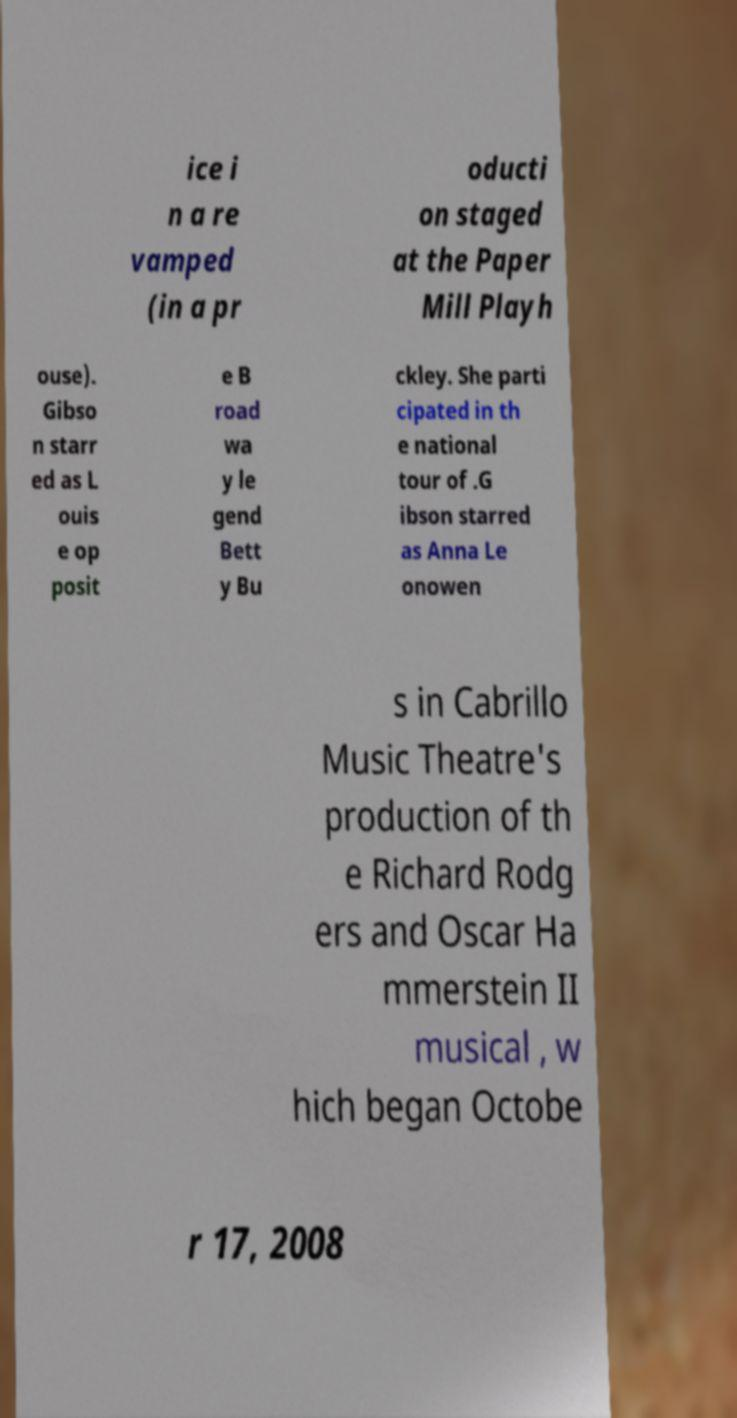What messages or text are displayed in this image? I need them in a readable, typed format. ice i n a re vamped (in a pr oducti on staged at the Paper Mill Playh ouse). Gibso n starr ed as L ouis e op posit e B road wa y le gend Bett y Bu ckley. She parti cipated in th e national tour of .G ibson starred as Anna Le onowen s in Cabrillo Music Theatre's production of th e Richard Rodg ers and Oscar Ha mmerstein II musical , w hich began Octobe r 17, 2008 